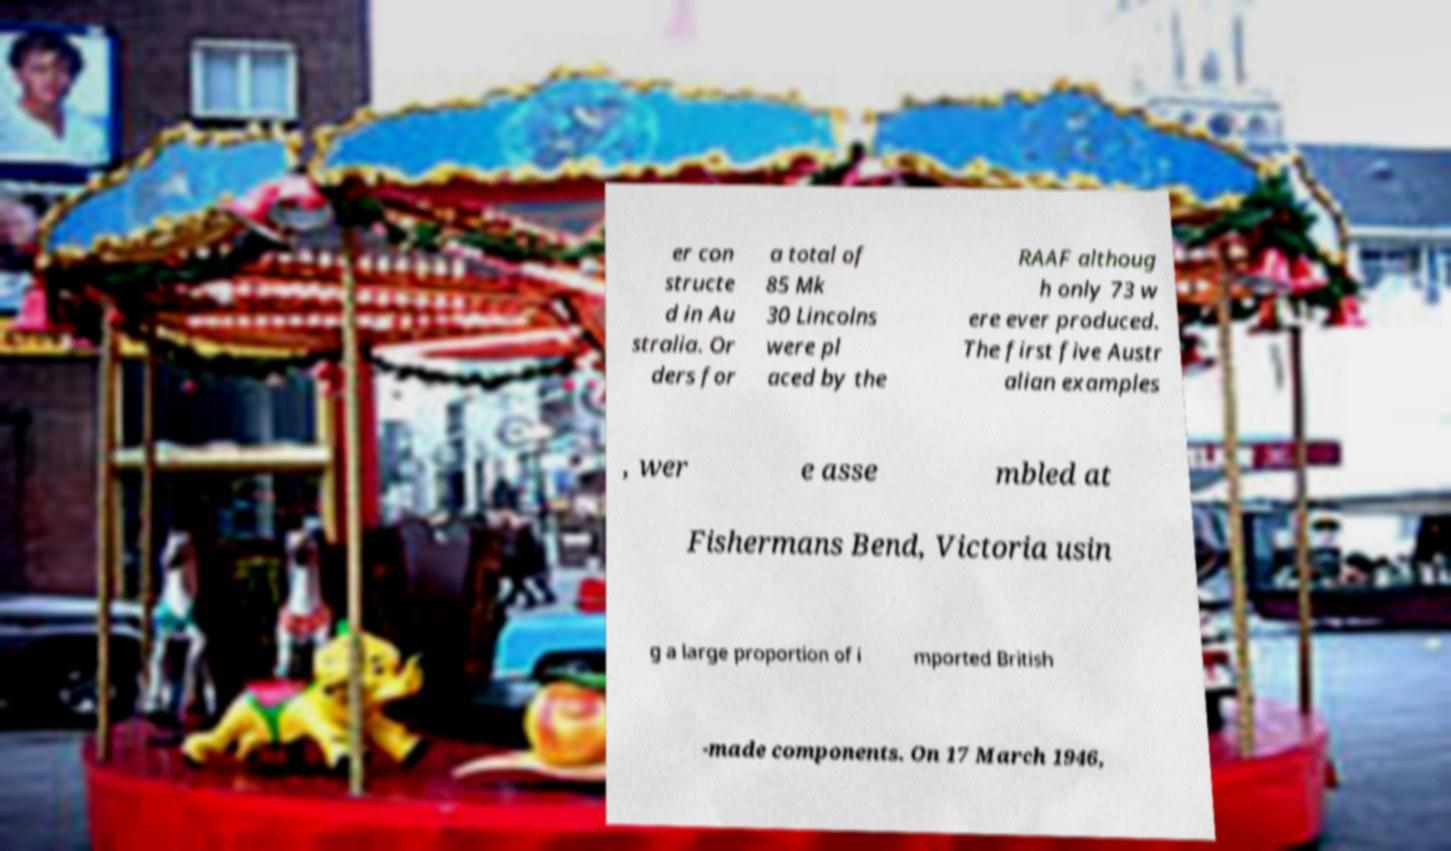Could you assist in decoding the text presented in this image and type it out clearly? er con structe d in Au stralia. Or ders for a total of 85 Mk 30 Lincolns were pl aced by the RAAF althoug h only 73 w ere ever produced. The first five Austr alian examples , wer e asse mbled at Fishermans Bend, Victoria usin g a large proportion of i mported British -made components. On 17 March 1946, 